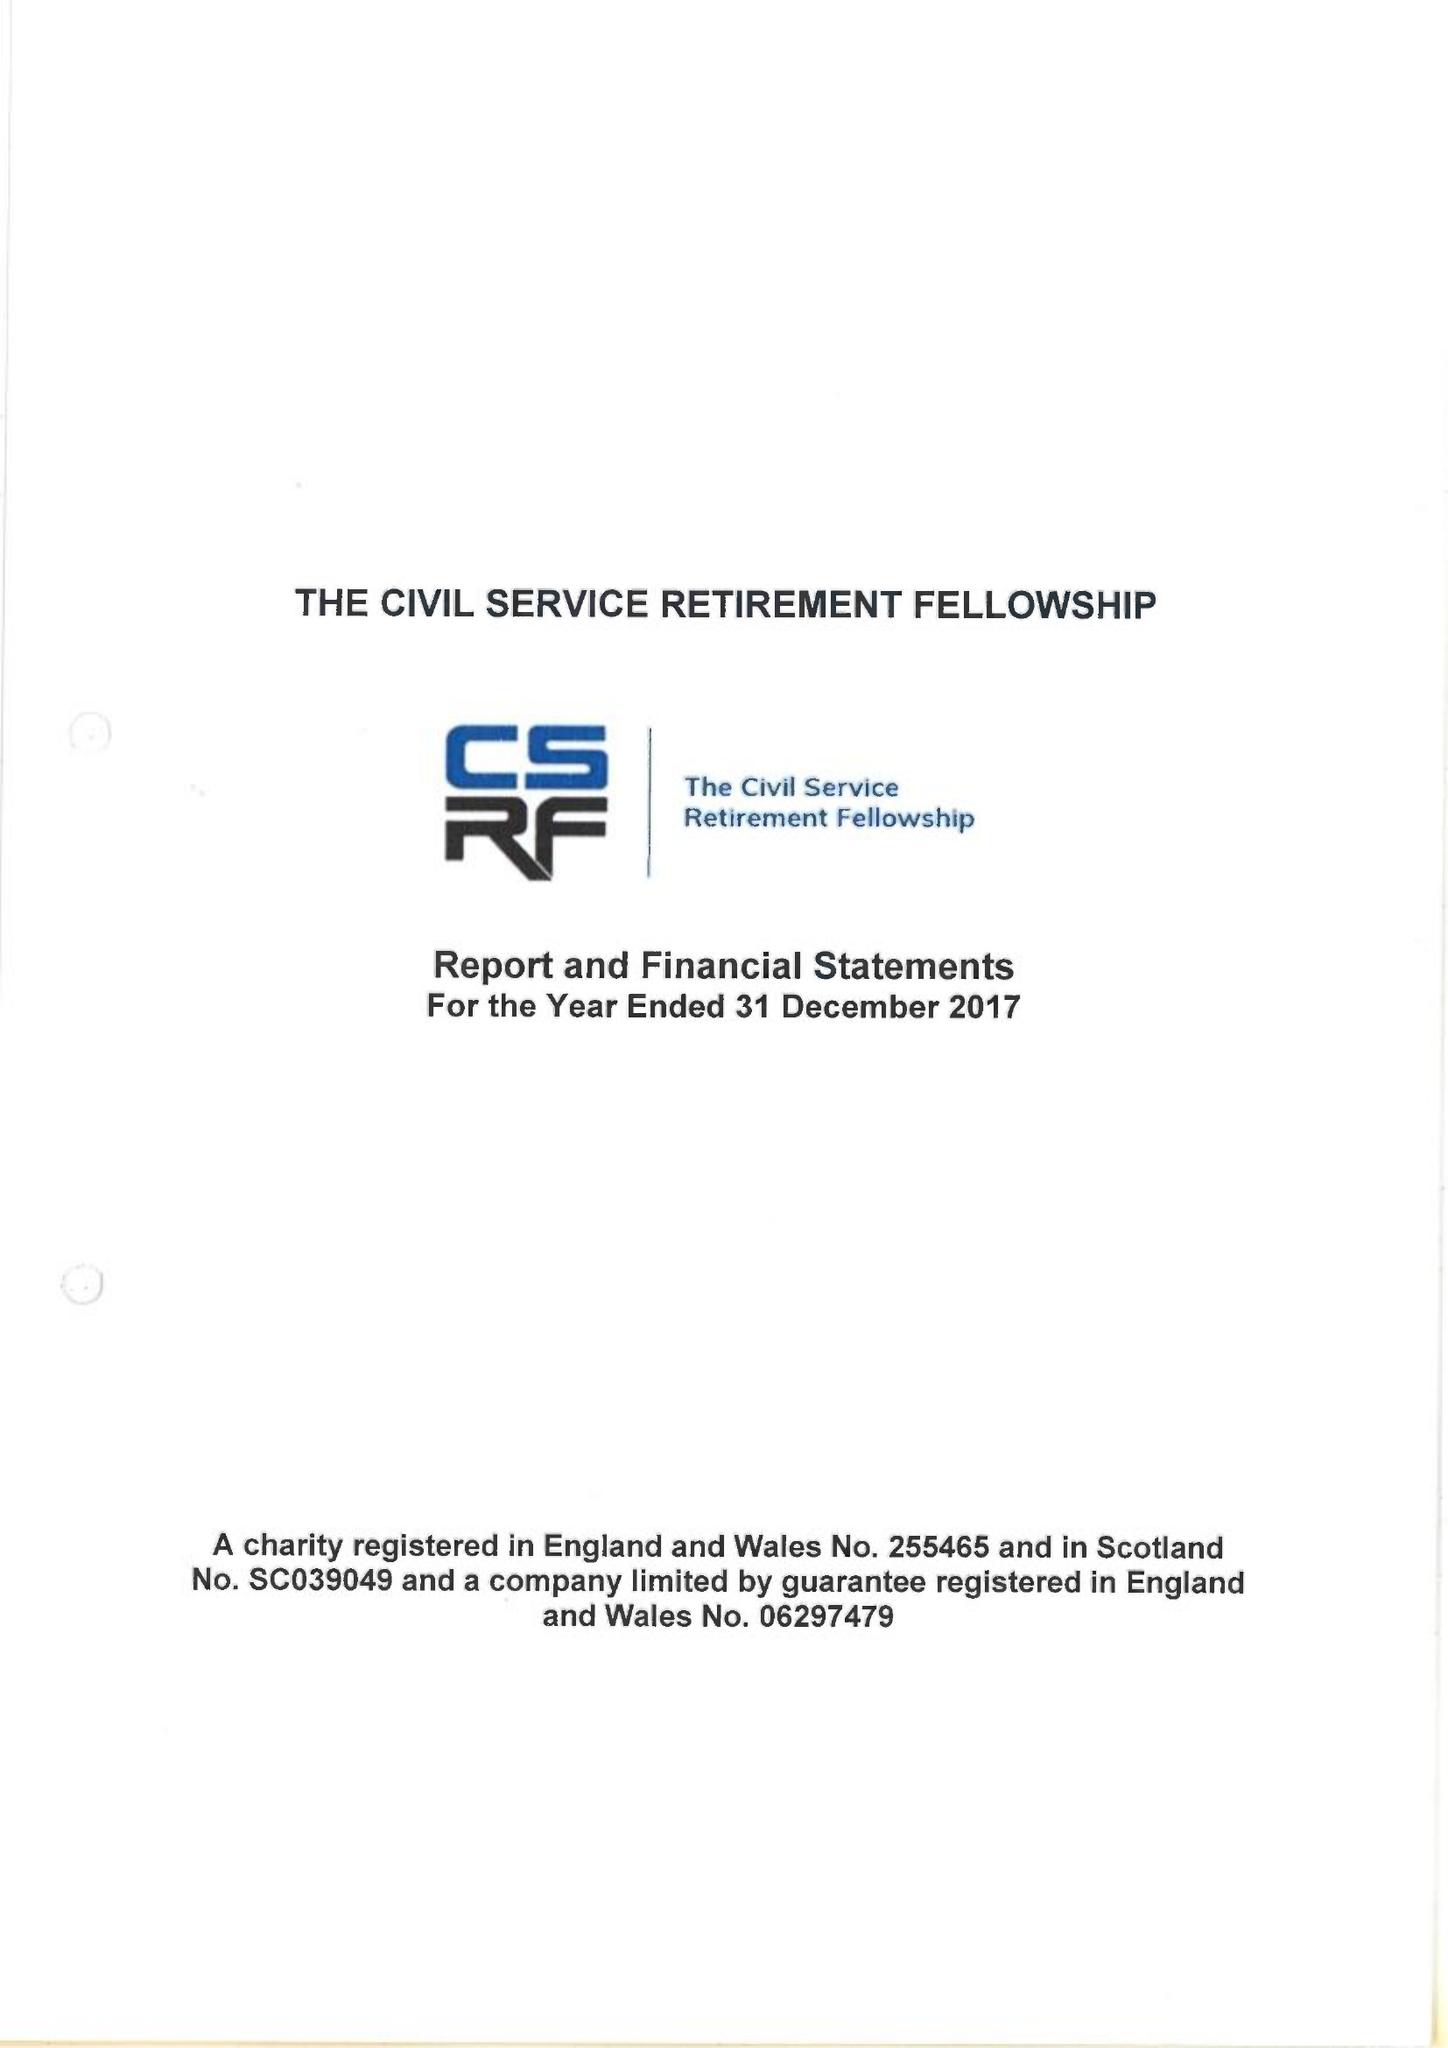What is the value for the address__street_line?
Answer the question using a single word or phrase. CLARENCE ROAD 